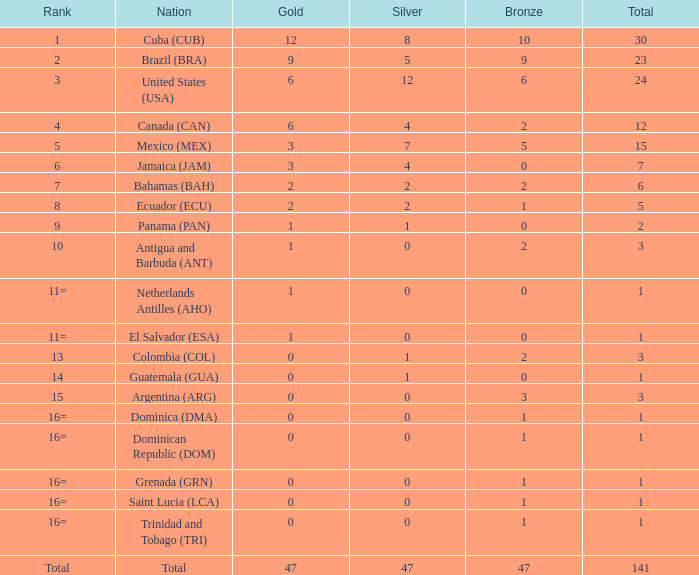How many bronze medals has the jamaican nation (jam) with a total under 7? 0.0. 